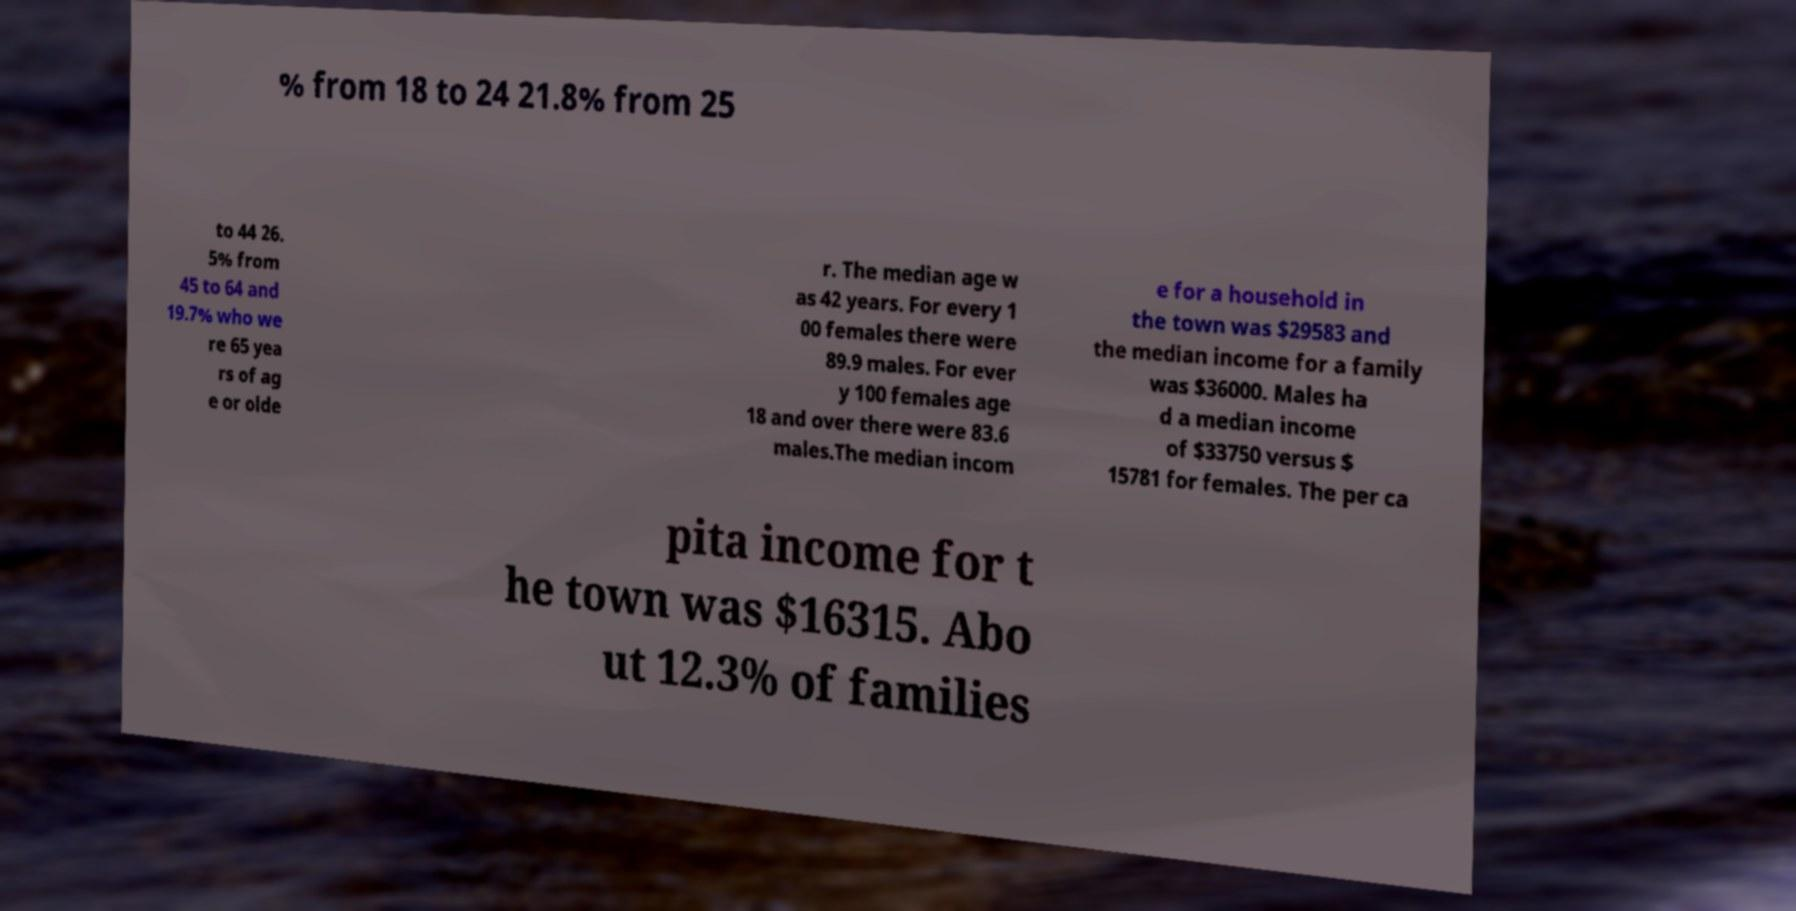Can you read and provide the text displayed in the image?This photo seems to have some interesting text. Can you extract and type it out for me? % from 18 to 24 21.8% from 25 to 44 26. 5% from 45 to 64 and 19.7% who we re 65 yea rs of ag e or olde r. The median age w as 42 years. For every 1 00 females there were 89.9 males. For ever y 100 females age 18 and over there were 83.6 males.The median incom e for a household in the town was $29583 and the median income for a family was $36000. Males ha d a median income of $33750 versus $ 15781 for females. The per ca pita income for t he town was $16315. Abo ut 12.3% of families 